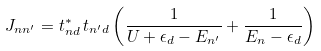<formula> <loc_0><loc_0><loc_500><loc_500>J _ { n n ^ { \prime } } = t _ { n d } ^ { \ast } \, t _ { n ^ { \prime } d } \left ( \frac { 1 } { U + \epsilon _ { d } - E _ { n ^ { \prime } } } + \frac { 1 } { E _ { n } - \epsilon _ { d } } \right )</formula> 